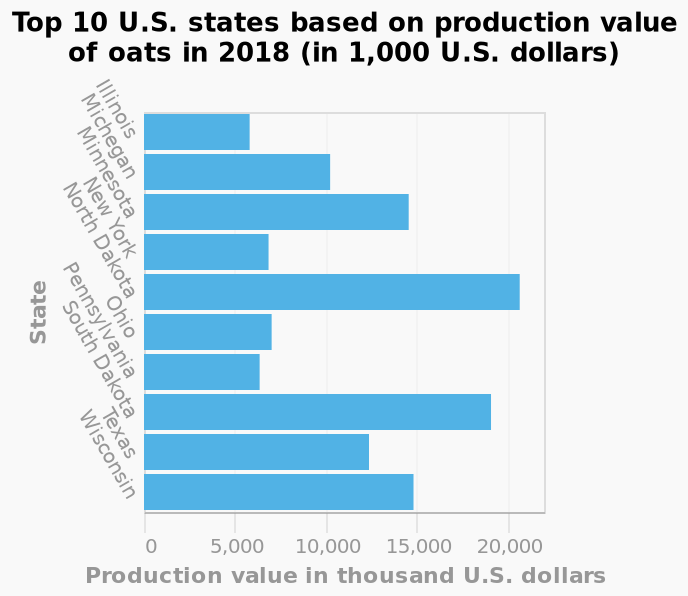<image>
Which state produced the highest production value? North Dakota Describe the following image in detail This is a bar graph titled Top 10 U.S. states based on production value of oats in 2018 (in 1,000 U.S. dollars). The y-axis plots State as categorical scale starting at Illinois and ending at Wisconsin while the x-axis shows Production value in thousand U.S. dollars on linear scale of range 0 to 20,000. Did any state produce less than 5000 thousand dollars? No state produced lower than 5000 thousand dollars. 